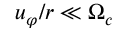<formula> <loc_0><loc_0><loc_500><loc_500>u _ { \varphi } / r \ll \Omega _ { c }</formula> 